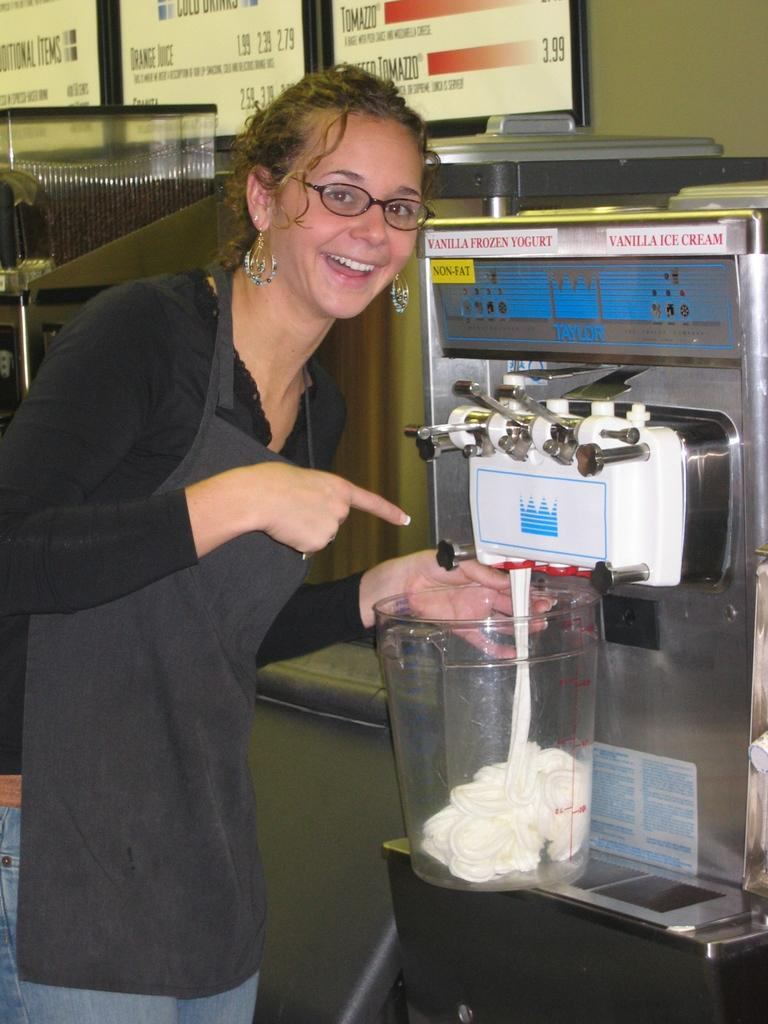<image>
Describe the image concisely. A woman points to a vanilla frozen yogurt machine. 